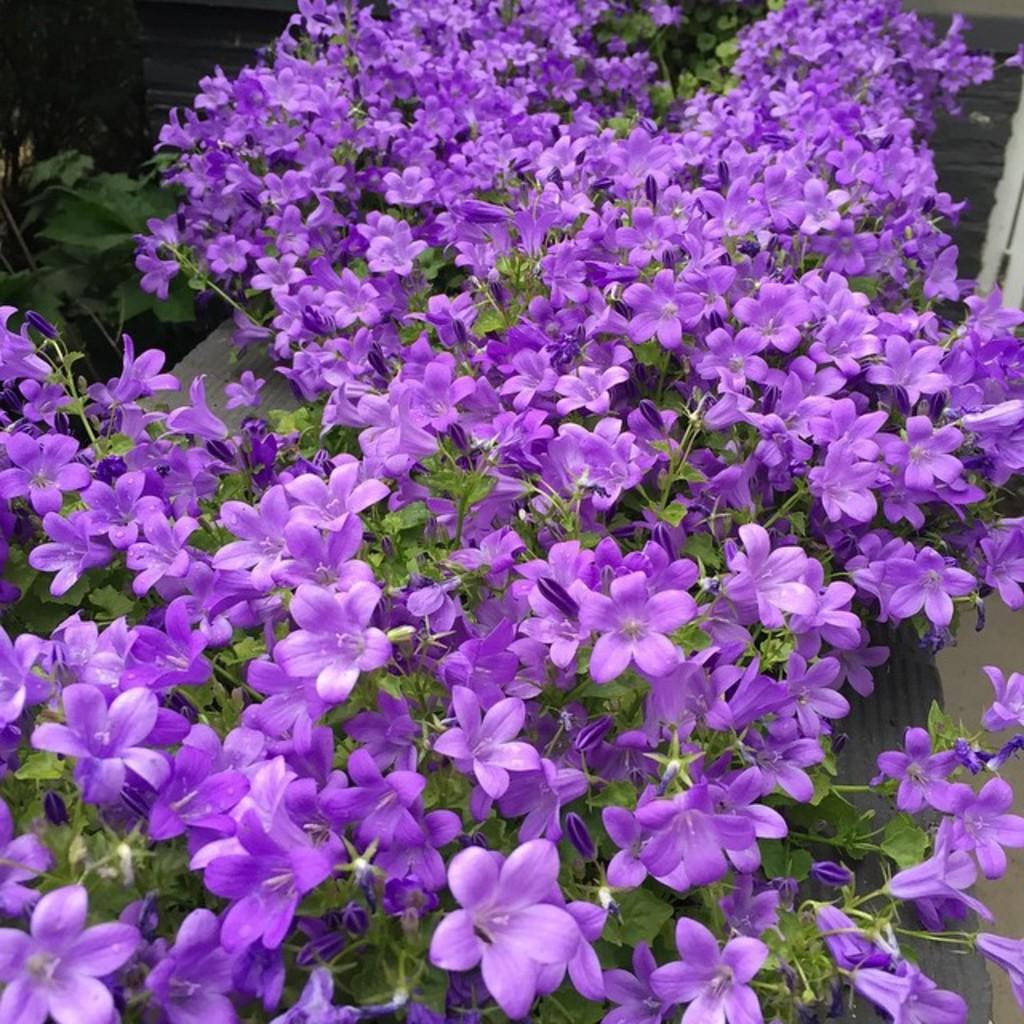In one or two sentences, can you explain what this image depicts? In this picture we can see plants with flowers and some objects. 